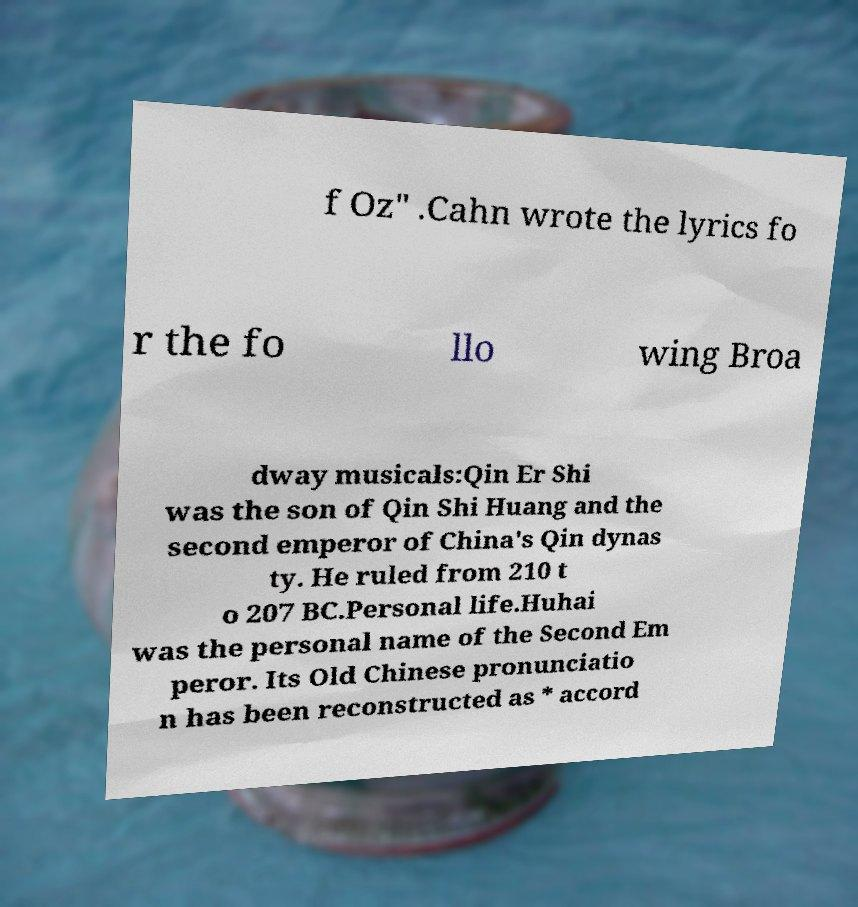Could you extract and type out the text from this image? f Oz" .Cahn wrote the lyrics fo r the fo llo wing Broa dway musicals:Qin Er Shi was the son of Qin Shi Huang and the second emperor of China's Qin dynas ty. He ruled from 210 t o 207 BC.Personal life.Huhai was the personal name of the Second Em peror. Its Old Chinese pronunciatio n has been reconstructed as * accord 